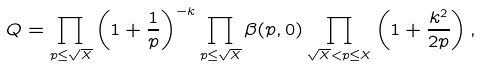<formula> <loc_0><loc_0><loc_500><loc_500>Q = \prod _ { p \leq \sqrt { X } } \left ( 1 + \frac { 1 } { p } \right ) ^ { - k } \prod _ { p \leq \sqrt { X } } \beta ( p , 0 ) \prod _ { \sqrt { X } < p \leq X } \left ( 1 + \frac { k ^ { 2 } } { 2 p } \right ) ,</formula> 